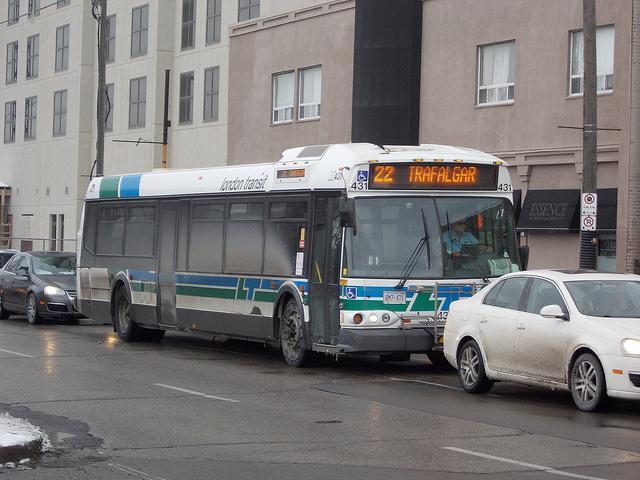How many cars can you see?
Give a very brief answer. 2. How many baby sheep are there?
Give a very brief answer. 0. 